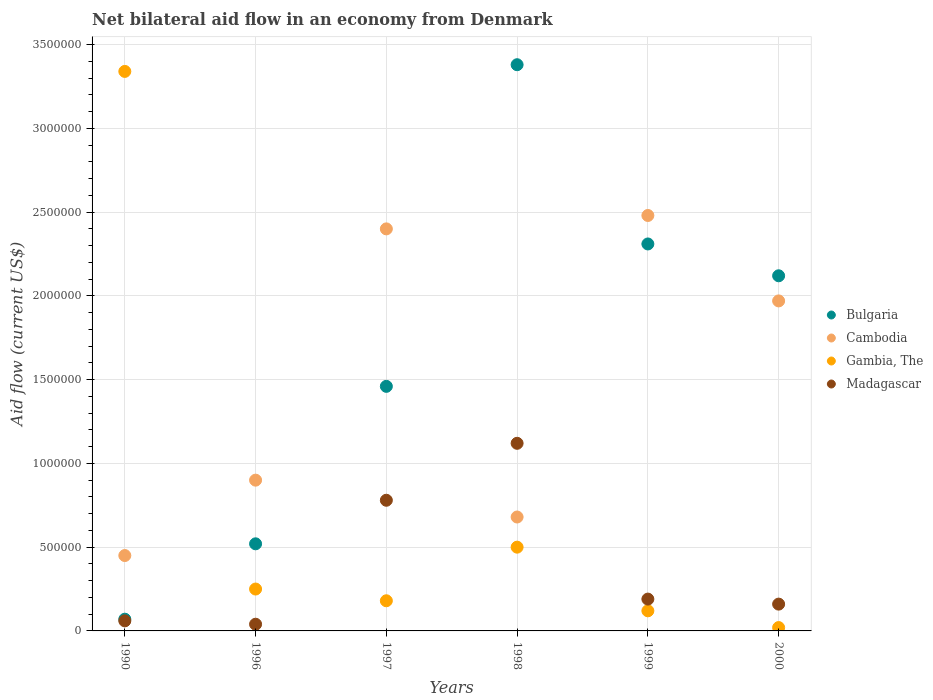How many different coloured dotlines are there?
Offer a terse response. 4. What is the net bilateral aid flow in Cambodia in 2000?
Give a very brief answer. 1.97e+06. Across all years, what is the maximum net bilateral aid flow in Gambia, The?
Make the answer very short. 3.34e+06. In which year was the net bilateral aid flow in Madagascar minimum?
Offer a very short reply. 1996. What is the total net bilateral aid flow in Madagascar in the graph?
Provide a short and direct response. 2.35e+06. What is the difference between the net bilateral aid flow in Cambodia in 1999 and the net bilateral aid flow in Gambia, The in 2000?
Your response must be concise. 2.46e+06. What is the average net bilateral aid flow in Madagascar per year?
Provide a succinct answer. 3.92e+05. In the year 1997, what is the difference between the net bilateral aid flow in Gambia, The and net bilateral aid flow in Cambodia?
Offer a terse response. -2.22e+06. In how many years, is the net bilateral aid flow in Cambodia greater than 2900000 US$?
Provide a succinct answer. 0. What is the ratio of the net bilateral aid flow in Cambodia in 1990 to that in 1998?
Offer a very short reply. 0.66. What is the difference between the highest and the second highest net bilateral aid flow in Bulgaria?
Give a very brief answer. 1.07e+06. What is the difference between the highest and the lowest net bilateral aid flow in Gambia, The?
Offer a terse response. 3.32e+06. Is it the case that in every year, the sum of the net bilateral aid flow in Gambia, The and net bilateral aid flow in Madagascar  is greater than the sum of net bilateral aid flow in Cambodia and net bilateral aid flow in Bulgaria?
Keep it short and to the point. No. Is it the case that in every year, the sum of the net bilateral aid flow in Bulgaria and net bilateral aid flow in Madagascar  is greater than the net bilateral aid flow in Gambia, The?
Ensure brevity in your answer.  No. Does the net bilateral aid flow in Gambia, The monotonically increase over the years?
Your answer should be very brief. No. How many dotlines are there?
Your answer should be very brief. 4. Are the values on the major ticks of Y-axis written in scientific E-notation?
Offer a terse response. No. Does the graph contain grids?
Keep it short and to the point. Yes. Where does the legend appear in the graph?
Your response must be concise. Center right. How are the legend labels stacked?
Provide a succinct answer. Vertical. What is the title of the graph?
Provide a short and direct response. Net bilateral aid flow in an economy from Denmark. Does "Israel" appear as one of the legend labels in the graph?
Your response must be concise. No. What is the label or title of the X-axis?
Offer a terse response. Years. What is the label or title of the Y-axis?
Provide a short and direct response. Aid flow (current US$). What is the Aid flow (current US$) of Bulgaria in 1990?
Offer a very short reply. 7.00e+04. What is the Aid flow (current US$) in Gambia, The in 1990?
Offer a very short reply. 3.34e+06. What is the Aid flow (current US$) in Madagascar in 1990?
Offer a terse response. 6.00e+04. What is the Aid flow (current US$) of Bulgaria in 1996?
Provide a short and direct response. 5.20e+05. What is the Aid flow (current US$) of Cambodia in 1996?
Make the answer very short. 9.00e+05. What is the Aid flow (current US$) of Bulgaria in 1997?
Ensure brevity in your answer.  1.46e+06. What is the Aid flow (current US$) in Cambodia in 1997?
Ensure brevity in your answer.  2.40e+06. What is the Aid flow (current US$) of Gambia, The in 1997?
Give a very brief answer. 1.80e+05. What is the Aid flow (current US$) of Madagascar in 1997?
Provide a succinct answer. 7.80e+05. What is the Aid flow (current US$) of Bulgaria in 1998?
Make the answer very short. 3.38e+06. What is the Aid flow (current US$) of Cambodia in 1998?
Your answer should be very brief. 6.80e+05. What is the Aid flow (current US$) in Gambia, The in 1998?
Give a very brief answer. 5.00e+05. What is the Aid flow (current US$) in Madagascar in 1998?
Provide a succinct answer. 1.12e+06. What is the Aid flow (current US$) in Bulgaria in 1999?
Ensure brevity in your answer.  2.31e+06. What is the Aid flow (current US$) in Cambodia in 1999?
Provide a short and direct response. 2.48e+06. What is the Aid flow (current US$) of Madagascar in 1999?
Your response must be concise. 1.90e+05. What is the Aid flow (current US$) of Bulgaria in 2000?
Your response must be concise. 2.12e+06. What is the Aid flow (current US$) of Cambodia in 2000?
Offer a terse response. 1.97e+06. What is the Aid flow (current US$) in Gambia, The in 2000?
Your response must be concise. 2.00e+04. Across all years, what is the maximum Aid flow (current US$) in Bulgaria?
Give a very brief answer. 3.38e+06. Across all years, what is the maximum Aid flow (current US$) in Cambodia?
Make the answer very short. 2.48e+06. Across all years, what is the maximum Aid flow (current US$) of Gambia, The?
Your answer should be compact. 3.34e+06. Across all years, what is the maximum Aid flow (current US$) of Madagascar?
Make the answer very short. 1.12e+06. Across all years, what is the minimum Aid flow (current US$) in Bulgaria?
Your answer should be very brief. 7.00e+04. Across all years, what is the minimum Aid flow (current US$) in Madagascar?
Offer a very short reply. 4.00e+04. What is the total Aid flow (current US$) in Bulgaria in the graph?
Ensure brevity in your answer.  9.86e+06. What is the total Aid flow (current US$) in Cambodia in the graph?
Offer a very short reply. 8.88e+06. What is the total Aid flow (current US$) in Gambia, The in the graph?
Your response must be concise. 4.41e+06. What is the total Aid flow (current US$) in Madagascar in the graph?
Provide a succinct answer. 2.35e+06. What is the difference between the Aid flow (current US$) of Bulgaria in 1990 and that in 1996?
Make the answer very short. -4.50e+05. What is the difference between the Aid flow (current US$) in Cambodia in 1990 and that in 1996?
Offer a very short reply. -4.50e+05. What is the difference between the Aid flow (current US$) in Gambia, The in 1990 and that in 1996?
Ensure brevity in your answer.  3.09e+06. What is the difference between the Aid flow (current US$) of Bulgaria in 1990 and that in 1997?
Your answer should be very brief. -1.39e+06. What is the difference between the Aid flow (current US$) in Cambodia in 1990 and that in 1997?
Make the answer very short. -1.95e+06. What is the difference between the Aid flow (current US$) in Gambia, The in 1990 and that in 1997?
Your response must be concise. 3.16e+06. What is the difference between the Aid flow (current US$) in Madagascar in 1990 and that in 1997?
Provide a succinct answer. -7.20e+05. What is the difference between the Aid flow (current US$) in Bulgaria in 1990 and that in 1998?
Offer a very short reply. -3.31e+06. What is the difference between the Aid flow (current US$) in Cambodia in 1990 and that in 1998?
Offer a very short reply. -2.30e+05. What is the difference between the Aid flow (current US$) of Gambia, The in 1990 and that in 1998?
Provide a succinct answer. 2.84e+06. What is the difference between the Aid flow (current US$) in Madagascar in 1990 and that in 1998?
Give a very brief answer. -1.06e+06. What is the difference between the Aid flow (current US$) in Bulgaria in 1990 and that in 1999?
Provide a succinct answer. -2.24e+06. What is the difference between the Aid flow (current US$) of Cambodia in 1990 and that in 1999?
Keep it short and to the point. -2.03e+06. What is the difference between the Aid flow (current US$) of Gambia, The in 1990 and that in 1999?
Your response must be concise. 3.22e+06. What is the difference between the Aid flow (current US$) in Bulgaria in 1990 and that in 2000?
Offer a very short reply. -2.05e+06. What is the difference between the Aid flow (current US$) in Cambodia in 1990 and that in 2000?
Provide a short and direct response. -1.52e+06. What is the difference between the Aid flow (current US$) of Gambia, The in 1990 and that in 2000?
Provide a succinct answer. 3.32e+06. What is the difference between the Aid flow (current US$) in Madagascar in 1990 and that in 2000?
Provide a succinct answer. -1.00e+05. What is the difference between the Aid flow (current US$) of Bulgaria in 1996 and that in 1997?
Offer a terse response. -9.40e+05. What is the difference between the Aid flow (current US$) of Cambodia in 1996 and that in 1997?
Your answer should be compact. -1.50e+06. What is the difference between the Aid flow (current US$) in Gambia, The in 1996 and that in 1997?
Your answer should be compact. 7.00e+04. What is the difference between the Aid flow (current US$) in Madagascar in 1996 and that in 1997?
Provide a succinct answer. -7.40e+05. What is the difference between the Aid flow (current US$) of Bulgaria in 1996 and that in 1998?
Offer a very short reply. -2.86e+06. What is the difference between the Aid flow (current US$) of Madagascar in 1996 and that in 1998?
Make the answer very short. -1.08e+06. What is the difference between the Aid flow (current US$) of Bulgaria in 1996 and that in 1999?
Offer a very short reply. -1.79e+06. What is the difference between the Aid flow (current US$) of Cambodia in 1996 and that in 1999?
Make the answer very short. -1.58e+06. What is the difference between the Aid flow (current US$) in Madagascar in 1996 and that in 1999?
Your answer should be compact. -1.50e+05. What is the difference between the Aid flow (current US$) of Bulgaria in 1996 and that in 2000?
Make the answer very short. -1.60e+06. What is the difference between the Aid flow (current US$) of Cambodia in 1996 and that in 2000?
Provide a succinct answer. -1.07e+06. What is the difference between the Aid flow (current US$) in Madagascar in 1996 and that in 2000?
Your answer should be compact. -1.20e+05. What is the difference between the Aid flow (current US$) in Bulgaria in 1997 and that in 1998?
Your answer should be very brief. -1.92e+06. What is the difference between the Aid flow (current US$) of Cambodia in 1997 and that in 1998?
Provide a short and direct response. 1.72e+06. What is the difference between the Aid flow (current US$) in Gambia, The in 1997 and that in 1998?
Give a very brief answer. -3.20e+05. What is the difference between the Aid flow (current US$) of Bulgaria in 1997 and that in 1999?
Keep it short and to the point. -8.50e+05. What is the difference between the Aid flow (current US$) in Cambodia in 1997 and that in 1999?
Offer a terse response. -8.00e+04. What is the difference between the Aid flow (current US$) of Gambia, The in 1997 and that in 1999?
Provide a succinct answer. 6.00e+04. What is the difference between the Aid flow (current US$) in Madagascar in 1997 and that in 1999?
Your response must be concise. 5.90e+05. What is the difference between the Aid flow (current US$) in Bulgaria in 1997 and that in 2000?
Provide a short and direct response. -6.60e+05. What is the difference between the Aid flow (current US$) of Madagascar in 1997 and that in 2000?
Offer a very short reply. 6.20e+05. What is the difference between the Aid flow (current US$) in Bulgaria in 1998 and that in 1999?
Provide a succinct answer. 1.07e+06. What is the difference between the Aid flow (current US$) in Cambodia in 1998 and that in 1999?
Provide a short and direct response. -1.80e+06. What is the difference between the Aid flow (current US$) in Gambia, The in 1998 and that in 1999?
Give a very brief answer. 3.80e+05. What is the difference between the Aid flow (current US$) of Madagascar in 1998 and that in 1999?
Offer a terse response. 9.30e+05. What is the difference between the Aid flow (current US$) of Bulgaria in 1998 and that in 2000?
Make the answer very short. 1.26e+06. What is the difference between the Aid flow (current US$) in Cambodia in 1998 and that in 2000?
Make the answer very short. -1.29e+06. What is the difference between the Aid flow (current US$) of Gambia, The in 1998 and that in 2000?
Your response must be concise. 4.80e+05. What is the difference between the Aid flow (current US$) in Madagascar in 1998 and that in 2000?
Ensure brevity in your answer.  9.60e+05. What is the difference between the Aid flow (current US$) in Bulgaria in 1999 and that in 2000?
Ensure brevity in your answer.  1.90e+05. What is the difference between the Aid flow (current US$) of Cambodia in 1999 and that in 2000?
Offer a terse response. 5.10e+05. What is the difference between the Aid flow (current US$) of Gambia, The in 1999 and that in 2000?
Offer a terse response. 1.00e+05. What is the difference between the Aid flow (current US$) in Madagascar in 1999 and that in 2000?
Provide a succinct answer. 3.00e+04. What is the difference between the Aid flow (current US$) of Bulgaria in 1990 and the Aid flow (current US$) of Cambodia in 1996?
Give a very brief answer. -8.30e+05. What is the difference between the Aid flow (current US$) in Cambodia in 1990 and the Aid flow (current US$) in Gambia, The in 1996?
Make the answer very short. 2.00e+05. What is the difference between the Aid flow (current US$) of Cambodia in 1990 and the Aid flow (current US$) of Madagascar in 1996?
Offer a terse response. 4.10e+05. What is the difference between the Aid flow (current US$) of Gambia, The in 1990 and the Aid flow (current US$) of Madagascar in 1996?
Ensure brevity in your answer.  3.30e+06. What is the difference between the Aid flow (current US$) of Bulgaria in 1990 and the Aid flow (current US$) of Cambodia in 1997?
Provide a short and direct response. -2.33e+06. What is the difference between the Aid flow (current US$) in Bulgaria in 1990 and the Aid flow (current US$) in Gambia, The in 1997?
Keep it short and to the point. -1.10e+05. What is the difference between the Aid flow (current US$) in Bulgaria in 1990 and the Aid flow (current US$) in Madagascar in 1997?
Provide a short and direct response. -7.10e+05. What is the difference between the Aid flow (current US$) of Cambodia in 1990 and the Aid flow (current US$) of Gambia, The in 1997?
Your response must be concise. 2.70e+05. What is the difference between the Aid flow (current US$) in Cambodia in 1990 and the Aid flow (current US$) in Madagascar in 1997?
Make the answer very short. -3.30e+05. What is the difference between the Aid flow (current US$) in Gambia, The in 1990 and the Aid flow (current US$) in Madagascar in 1997?
Your answer should be very brief. 2.56e+06. What is the difference between the Aid flow (current US$) of Bulgaria in 1990 and the Aid flow (current US$) of Cambodia in 1998?
Keep it short and to the point. -6.10e+05. What is the difference between the Aid flow (current US$) of Bulgaria in 1990 and the Aid flow (current US$) of Gambia, The in 1998?
Offer a terse response. -4.30e+05. What is the difference between the Aid flow (current US$) in Bulgaria in 1990 and the Aid flow (current US$) in Madagascar in 1998?
Make the answer very short. -1.05e+06. What is the difference between the Aid flow (current US$) in Cambodia in 1990 and the Aid flow (current US$) in Gambia, The in 1998?
Offer a very short reply. -5.00e+04. What is the difference between the Aid flow (current US$) of Cambodia in 1990 and the Aid flow (current US$) of Madagascar in 1998?
Offer a very short reply. -6.70e+05. What is the difference between the Aid flow (current US$) of Gambia, The in 1990 and the Aid flow (current US$) of Madagascar in 1998?
Your response must be concise. 2.22e+06. What is the difference between the Aid flow (current US$) in Bulgaria in 1990 and the Aid flow (current US$) in Cambodia in 1999?
Your answer should be compact. -2.41e+06. What is the difference between the Aid flow (current US$) of Bulgaria in 1990 and the Aid flow (current US$) of Gambia, The in 1999?
Give a very brief answer. -5.00e+04. What is the difference between the Aid flow (current US$) in Cambodia in 1990 and the Aid flow (current US$) in Gambia, The in 1999?
Your response must be concise. 3.30e+05. What is the difference between the Aid flow (current US$) of Gambia, The in 1990 and the Aid flow (current US$) of Madagascar in 1999?
Your answer should be very brief. 3.15e+06. What is the difference between the Aid flow (current US$) of Bulgaria in 1990 and the Aid flow (current US$) of Cambodia in 2000?
Your answer should be compact. -1.90e+06. What is the difference between the Aid flow (current US$) in Bulgaria in 1990 and the Aid flow (current US$) in Gambia, The in 2000?
Provide a short and direct response. 5.00e+04. What is the difference between the Aid flow (current US$) in Gambia, The in 1990 and the Aid flow (current US$) in Madagascar in 2000?
Ensure brevity in your answer.  3.18e+06. What is the difference between the Aid flow (current US$) in Bulgaria in 1996 and the Aid flow (current US$) in Cambodia in 1997?
Offer a very short reply. -1.88e+06. What is the difference between the Aid flow (current US$) in Cambodia in 1996 and the Aid flow (current US$) in Gambia, The in 1997?
Offer a very short reply. 7.20e+05. What is the difference between the Aid flow (current US$) in Cambodia in 1996 and the Aid flow (current US$) in Madagascar in 1997?
Offer a terse response. 1.20e+05. What is the difference between the Aid flow (current US$) in Gambia, The in 1996 and the Aid flow (current US$) in Madagascar in 1997?
Your answer should be very brief. -5.30e+05. What is the difference between the Aid flow (current US$) of Bulgaria in 1996 and the Aid flow (current US$) of Gambia, The in 1998?
Your answer should be compact. 2.00e+04. What is the difference between the Aid flow (current US$) of Bulgaria in 1996 and the Aid flow (current US$) of Madagascar in 1998?
Make the answer very short. -6.00e+05. What is the difference between the Aid flow (current US$) in Cambodia in 1996 and the Aid flow (current US$) in Madagascar in 1998?
Provide a succinct answer. -2.20e+05. What is the difference between the Aid flow (current US$) of Gambia, The in 1996 and the Aid flow (current US$) of Madagascar in 1998?
Your answer should be compact. -8.70e+05. What is the difference between the Aid flow (current US$) of Bulgaria in 1996 and the Aid flow (current US$) of Cambodia in 1999?
Make the answer very short. -1.96e+06. What is the difference between the Aid flow (current US$) of Bulgaria in 1996 and the Aid flow (current US$) of Gambia, The in 1999?
Your response must be concise. 4.00e+05. What is the difference between the Aid flow (current US$) in Bulgaria in 1996 and the Aid flow (current US$) in Madagascar in 1999?
Give a very brief answer. 3.30e+05. What is the difference between the Aid flow (current US$) in Cambodia in 1996 and the Aid flow (current US$) in Gambia, The in 1999?
Your answer should be very brief. 7.80e+05. What is the difference between the Aid flow (current US$) in Cambodia in 1996 and the Aid flow (current US$) in Madagascar in 1999?
Your answer should be compact. 7.10e+05. What is the difference between the Aid flow (current US$) of Bulgaria in 1996 and the Aid flow (current US$) of Cambodia in 2000?
Give a very brief answer. -1.45e+06. What is the difference between the Aid flow (current US$) of Bulgaria in 1996 and the Aid flow (current US$) of Madagascar in 2000?
Your answer should be very brief. 3.60e+05. What is the difference between the Aid flow (current US$) in Cambodia in 1996 and the Aid flow (current US$) in Gambia, The in 2000?
Ensure brevity in your answer.  8.80e+05. What is the difference between the Aid flow (current US$) of Cambodia in 1996 and the Aid flow (current US$) of Madagascar in 2000?
Your response must be concise. 7.40e+05. What is the difference between the Aid flow (current US$) of Bulgaria in 1997 and the Aid flow (current US$) of Cambodia in 1998?
Your answer should be very brief. 7.80e+05. What is the difference between the Aid flow (current US$) in Bulgaria in 1997 and the Aid flow (current US$) in Gambia, The in 1998?
Make the answer very short. 9.60e+05. What is the difference between the Aid flow (current US$) in Cambodia in 1997 and the Aid flow (current US$) in Gambia, The in 1998?
Your response must be concise. 1.90e+06. What is the difference between the Aid flow (current US$) in Cambodia in 1997 and the Aid flow (current US$) in Madagascar in 1998?
Provide a succinct answer. 1.28e+06. What is the difference between the Aid flow (current US$) in Gambia, The in 1997 and the Aid flow (current US$) in Madagascar in 1998?
Give a very brief answer. -9.40e+05. What is the difference between the Aid flow (current US$) in Bulgaria in 1997 and the Aid flow (current US$) in Cambodia in 1999?
Keep it short and to the point. -1.02e+06. What is the difference between the Aid flow (current US$) of Bulgaria in 1997 and the Aid flow (current US$) of Gambia, The in 1999?
Ensure brevity in your answer.  1.34e+06. What is the difference between the Aid flow (current US$) of Bulgaria in 1997 and the Aid flow (current US$) of Madagascar in 1999?
Provide a succinct answer. 1.27e+06. What is the difference between the Aid flow (current US$) of Cambodia in 1997 and the Aid flow (current US$) of Gambia, The in 1999?
Provide a short and direct response. 2.28e+06. What is the difference between the Aid flow (current US$) of Cambodia in 1997 and the Aid flow (current US$) of Madagascar in 1999?
Ensure brevity in your answer.  2.21e+06. What is the difference between the Aid flow (current US$) in Gambia, The in 1997 and the Aid flow (current US$) in Madagascar in 1999?
Provide a succinct answer. -10000. What is the difference between the Aid flow (current US$) of Bulgaria in 1997 and the Aid flow (current US$) of Cambodia in 2000?
Provide a succinct answer. -5.10e+05. What is the difference between the Aid flow (current US$) of Bulgaria in 1997 and the Aid flow (current US$) of Gambia, The in 2000?
Your response must be concise. 1.44e+06. What is the difference between the Aid flow (current US$) of Bulgaria in 1997 and the Aid flow (current US$) of Madagascar in 2000?
Give a very brief answer. 1.30e+06. What is the difference between the Aid flow (current US$) of Cambodia in 1997 and the Aid flow (current US$) of Gambia, The in 2000?
Your response must be concise. 2.38e+06. What is the difference between the Aid flow (current US$) in Cambodia in 1997 and the Aid flow (current US$) in Madagascar in 2000?
Provide a short and direct response. 2.24e+06. What is the difference between the Aid flow (current US$) in Gambia, The in 1997 and the Aid flow (current US$) in Madagascar in 2000?
Offer a very short reply. 2.00e+04. What is the difference between the Aid flow (current US$) of Bulgaria in 1998 and the Aid flow (current US$) of Gambia, The in 1999?
Make the answer very short. 3.26e+06. What is the difference between the Aid flow (current US$) in Bulgaria in 1998 and the Aid flow (current US$) in Madagascar in 1999?
Your answer should be compact. 3.19e+06. What is the difference between the Aid flow (current US$) of Cambodia in 1998 and the Aid flow (current US$) of Gambia, The in 1999?
Offer a terse response. 5.60e+05. What is the difference between the Aid flow (current US$) in Gambia, The in 1998 and the Aid flow (current US$) in Madagascar in 1999?
Provide a short and direct response. 3.10e+05. What is the difference between the Aid flow (current US$) of Bulgaria in 1998 and the Aid flow (current US$) of Cambodia in 2000?
Your response must be concise. 1.41e+06. What is the difference between the Aid flow (current US$) of Bulgaria in 1998 and the Aid flow (current US$) of Gambia, The in 2000?
Make the answer very short. 3.36e+06. What is the difference between the Aid flow (current US$) of Bulgaria in 1998 and the Aid flow (current US$) of Madagascar in 2000?
Keep it short and to the point. 3.22e+06. What is the difference between the Aid flow (current US$) of Cambodia in 1998 and the Aid flow (current US$) of Madagascar in 2000?
Make the answer very short. 5.20e+05. What is the difference between the Aid flow (current US$) in Bulgaria in 1999 and the Aid flow (current US$) in Cambodia in 2000?
Keep it short and to the point. 3.40e+05. What is the difference between the Aid flow (current US$) in Bulgaria in 1999 and the Aid flow (current US$) in Gambia, The in 2000?
Your answer should be compact. 2.29e+06. What is the difference between the Aid flow (current US$) in Bulgaria in 1999 and the Aid flow (current US$) in Madagascar in 2000?
Your answer should be very brief. 2.15e+06. What is the difference between the Aid flow (current US$) of Cambodia in 1999 and the Aid flow (current US$) of Gambia, The in 2000?
Ensure brevity in your answer.  2.46e+06. What is the difference between the Aid flow (current US$) in Cambodia in 1999 and the Aid flow (current US$) in Madagascar in 2000?
Offer a very short reply. 2.32e+06. What is the average Aid flow (current US$) in Bulgaria per year?
Give a very brief answer. 1.64e+06. What is the average Aid flow (current US$) in Cambodia per year?
Provide a succinct answer. 1.48e+06. What is the average Aid flow (current US$) of Gambia, The per year?
Offer a terse response. 7.35e+05. What is the average Aid flow (current US$) of Madagascar per year?
Provide a short and direct response. 3.92e+05. In the year 1990, what is the difference between the Aid flow (current US$) of Bulgaria and Aid flow (current US$) of Cambodia?
Offer a terse response. -3.80e+05. In the year 1990, what is the difference between the Aid flow (current US$) of Bulgaria and Aid flow (current US$) of Gambia, The?
Ensure brevity in your answer.  -3.27e+06. In the year 1990, what is the difference between the Aid flow (current US$) in Bulgaria and Aid flow (current US$) in Madagascar?
Give a very brief answer. 10000. In the year 1990, what is the difference between the Aid flow (current US$) of Cambodia and Aid flow (current US$) of Gambia, The?
Your response must be concise. -2.89e+06. In the year 1990, what is the difference between the Aid flow (current US$) in Gambia, The and Aid flow (current US$) in Madagascar?
Provide a short and direct response. 3.28e+06. In the year 1996, what is the difference between the Aid flow (current US$) in Bulgaria and Aid flow (current US$) in Cambodia?
Give a very brief answer. -3.80e+05. In the year 1996, what is the difference between the Aid flow (current US$) in Bulgaria and Aid flow (current US$) in Gambia, The?
Give a very brief answer. 2.70e+05. In the year 1996, what is the difference between the Aid flow (current US$) in Cambodia and Aid flow (current US$) in Gambia, The?
Offer a terse response. 6.50e+05. In the year 1996, what is the difference between the Aid flow (current US$) in Cambodia and Aid flow (current US$) in Madagascar?
Ensure brevity in your answer.  8.60e+05. In the year 1997, what is the difference between the Aid flow (current US$) in Bulgaria and Aid flow (current US$) in Cambodia?
Your answer should be compact. -9.40e+05. In the year 1997, what is the difference between the Aid flow (current US$) in Bulgaria and Aid flow (current US$) in Gambia, The?
Make the answer very short. 1.28e+06. In the year 1997, what is the difference between the Aid flow (current US$) of Bulgaria and Aid flow (current US$) of Madagascar?
Keep it short and to the point. 6.80e+05. In the year 1997, what is the difference between the Aid flow (current US$) in Cambodia and Aid flow (current US$) in Gambia, The?
Provide a short and direct response. 2.22e+06. In the year 1997, what is the difference between the Aid flow (current US$) in Cambodia and Aid flow (current US$) in Madagascar?
Your answer should be very brief. 1.62e+06. In the year 1997, what is the difference between the Aid flow (current US$) of Gambia, The and Aid flow (current US$) of Madagascar?
Your response must be concise. -6.00e+05. In the year 1998, what is the difference between the Aid flow (current US$) of Bulgaria and Aid flow (current US$) of Cambodia?
Make the answer very short. 2.70e+06. In the year 1998, what is the difference between the Aid flow (current US$) in Bulgaria and Aid flow (current US$) in Gambia, The?
Ensure brevity in your answer.  2.88e+06. In the year 1998, what is the difference between the Aid flow (current US$) in Bulgaria and Aid flow (current US$) in Madagascar?
Ensure brevity in your answer.  2.26e+06. In the year 1998, what is the difference between the Aid flow (current US$) in Cambodia and Aid flow (current US$) in Madagascar?
Your answer should be compact. -4.40e+05. In the year 1998, what is the difference between the Aid flow (current US$) in Gambia, The and Aid flow (current US$) in Madagascar?
Offer a very short reply. -6.20e+05. In the year 1999, what is the difference between the Aid flow (current US$) in Bulgaria and Aid flow (current US$) in Cambodia?
Your response must be concise. -1.70e+05. In the year 1999, what is the difference between the Aid flow (current US$) in Bulgaria and Aid flow (current US$) in Gambia, The?
Keep it short and to the point. 2.19e+06. In the year 1999, what is the difference between the Aid flow (current US$) of Bulgaria and Aid flow (current US$) of Madagascar?
Offer a very short reply. 2.12e+06. In the year 1999, what is the difference between the Aid flow (current US$) in Cambodia and Aid flow (current US$) in Gambia, The?
Keep it short and to the point. 2.36e+06. In the year 1999, what is the difference between the Aid flow (current US$) of Cambodia and Aid flow (current US$) of Madagascar?
Your response must be concise. 2.29e+06. In the year 2000, what is the difference between the Aid flow (current US$) of Bulgaria and Aid flow (current US$) of Cambodia?
Keep it short and to the point. 1.50e+05. In the year 2000, what is the difference between the Aid flow (current US$) in Bulgaria and Aid flow (current US$) in Gambia, The?
Your response must be concise. 2.10e+06. In the year 2000, what is the difference between the Aid flow (current US$) in Bulgaria and Aid flow (current US$) in Madagascar?
Offer a terse response. 1.96e+06. In the year 2000, what is the difference between the Aid flow (current US$) of Cambodia and Aid flow (current US$) of Gambia, The?
Your answer should be very brief. 1.95e+06. In the year 2000, what is the difference between the Aid flow (current US$) in Cambodia and Aid flow (current US$) in Madagascar?
Your answer should be compact. 1.81e+06. What is the ratio of the Aid flow (current US$) of Bulgaria in 1990 to that in 1996?
Provide a succinct answer. 0.13. What is the ratio of the Aid flow (current US$) of Gambia, The in 1990 to that in 1996?
Your response must be concise. 13.36. What is the ratio of the Aid flow (current US$) of Madagascar in 1990 to that in 1996?
Offer a terse response. 1.5. What is the ratio of the Aid flow (current US$) in Bulgaria in 1990 to that in 1997?
Keep it short and to the point. 0.05. What is the ratio of the Aid flow (current US$) in Cambodia in 1990 to that in 1997?
Provide a short and direct response. 0.19. What is the ratio of the Aid flow (current US$) in Gambia, The in 1990 to that in 1997?
Give a very brief answer. 18.56. What is the ratio of the Aid flow (current US$) of Madagascar in 1990 to that in 1997?
Offer a terse response. 0.08. What is the ratio of the Aid flow (current US$) of Bulgaria in 1990 to that in 1998?
Give a very brief answer. 0.02. What is the ratio of the Aid flow (current US$) of Cambodia in 1990 to that in 1998?
Ensure brevity in your answer.  0.66. What is the ratio of the Aid flow (current US$) in Gambia, The in 1990 to that in 1998?
Provide a succinct answer. 6.68. What is the ratio of the Aid flow (current US$) in Madagascar in 1990 to that in 1998?
Offer a very short reply. 0.05. What is the ratio of the Aid flow (current US$) of Bulgaria in 1990 to that in 1999?
Provide a short and direct response. 0.03. What is the ratio of the Aid flow (current US$) of Cambodia in 1990 to that in 1999?
Keep it short and to the point. 0.18. What is the ratio of the Aid flow (current US$) of Gambia, The in 1990 to that in 1999?
Provide a short and direct response. 27.83. What is the ratio of the Aid flow (current US$) in Madagascar in 1990 to that in 1999?
Make the answer very short. 0.32. What is the ratio of the Aid flow (current US$) in Bulgaria in 1990 to that in 2000?
Make the answer very short. 0.03. What is the ratio of the Aid flow (current US$) of Cambodia in 1990 to that in 2000?
Your response must be concise. 0.23. What is the ratio of the Aid flow (current US$) of Gambia, The in 1990 to that in 2000?
Your response must be concise. 167. What is the ratio of the Aid flow (current US$) of Madagascar in 1990 to that in 2000?
Make the answer very short. 0.38. What is the ratio of the Aid flow (current US$) of Bulgaria in 1996 to that in 1997?
Keep it short and to the point. 0.36. What is the ratio of the Aid flow (current US$) in Gambia, The in 1996 to that in 1997?
Offer a terse response. 1.39. What is the ratio of the Aid flow (current US$) in Madagascar in 1996 to that in 1997?
Provide a succinct answer. 0.05. What is the ratio of the Aid flow (current US$) in Bulgaria in 1996 to that in 1998?
Keep it short and to the point. 0.15. What is the ratio of the Aid flow (current US$) in Cambodia in 1996 to that in 1998?
Your answer should be compact. 1.32. What is the ratio of the Aid flow (current US$) in Madagascar in 1996 to that in 1998?
Offer a very short reply. 0.04. What is the ratio of the Aid flow (current US$) of Bulgaria in 1996 to that in 1999?
Make the answer very short. 0.23. What is the ratio of the Aid flow (current US$) in Cambodia in 1996 to that in 1999?
Provide a succinct answer. 0.36. What is the ratio of the Aid flow (current US$) of Gambia, The in 1996 to that in 1999?
Ensure brevity in your answer.  2.08. What is the ratio of the Aid flow (current US$) of Madagascar in 1996 to that in 1999?
Your answer should be very brief. 0.21. What is the ratio of the Aid flow (current US$) of Bulgaria in 1996 to that in 2000?
Your response must be concise. 0.25. What is the ratio of the Aid flow (current US$) in Cambodia in 1996 to that in 2000?
Your answer should be very brief. 0.46. What is the ratio of the Aid flow (current US$) in Gambia, The in 1996 to that in 2000?
Offer a terse response. 12.5. What is the ratio of the Aid flow (current US$) in Bulgaria in 1997 to that in 1998?
Keep it short and to the point. 0.43. What is the ratio of the Aid flow (current US$) in Cambodia in 1997 to that in 1998?
Your response must be concise. 3.53. What is the ratio of the Aid flow (current US$) in Gambia, The in 1997 to that in 1998?
Your response must be concise. 0.36. What is the ratio of the Aid flow (current US$) in Madagascar in 1997 to that in 1998?
Provide a succinct answer. 0.7. What is the ratio of the Aid flow (current US$) in Bulgaria in 1997 to that in 1999?
Offer a terse response. 0.63. What is the ratio of the Aid flow (current US$) in Cambodia in 1997 to that in 1999?
Give a very brief answer. 0.97. What is the ratio of the Aid flow (current US$) in Madagascar in 1997 to that in 1999?
Offer a terse response. 4.11. What is the ratio of the Aid flow (current US$) in Bulgaria in 1997 to that in 2000?
Provide a short and direct response. 0.69. What is the ratio of the Aid flow (current US$) of Cambodia in 1997 to that in 2000?
Keep it short and to the point. 1.22. What is the ratio of the Aid flow (current US$) of Gambia, The in 1997 to that in 2000?
Your answer should be very brief. 9. What is the ratio of the Aid flow (current US$) of Madagascar in 1997 to that in 2000?
Provide a succinct answer. 4.88. What is the ratio of the Aid flow (current US$) of Bulgaria in 1998 to that in 1999?
Make the answer very short. 1.46. What is the ratio of the Aid flow (current US$) of Cambodia in 1998 to that in 1999?
Provide a succinct answer. 0.27. What is the ratio of the Aid flow (current US$) in Gambia, The in 1998 to that in 1999?
Ensure brevity in your answer.  4.17. What is the ratio of the Aid flow (current US$) of Madagascar in 1998 to that in 1999?
Keep it short and to the point. 5.89. What is the ratio of the Aid flow (current US$) of Bulgaria in 1998 to that in 2000?
Make the answer very short. 1.59. What is the ratio of the Aid flow (current US$) in Cambodia in 1998 to that in 2000?
Offer a very short reply. 0.35. What is the ratio of the Aid flow (current US$) of Bulgaria in 1999 to that in 2000?
Provide a short and direct response. 1.09. What is the ratio of the Aid flow (current US$) in Cambodia in 1999 to that in 2000?
Your answer should be very brief. 1.26. What is the ratio of the Aid flow (current US$) in Gambia, The in 1999 to that in 2000?
Offer a very short reply. 6. What is the ratio of the Aid flow (current US$) of Madagascar in 1999 to that in 2000?
Your answer should be very brief. 1.19. What is the difference between the highest and the second highest Aid flow (current US$) in Bulgaria?
Keep it short and to the point. 1.07e+06. What is the difference between the highest and the second highest Aid flow (current US$) in Gambia, The?
Offer a terse response. 2.84e+06. What is the difference between the highest and the second highest Aid flow (current US$) in Madagascar?
Your response must be concise. 3.40e+05. What is the difference between the highest and the lowest Aid flow (current US$) in Bulgaria?
Keep it short and to the point. 3.31e+06. What is the difference between the highest and the lowest Aid flow (current US$) in Cambodia?
Keep it short and to the point. 2.03e+06. What is the difference between the highest and the lowest Aid flow (current US$) of Gambia, The?
Offer a terse response. 3.32e+06. What is the difference between the highest and the lowest Aid flow (current US$) in Madagascar?
Your response must be concise. 1.08e+06. 